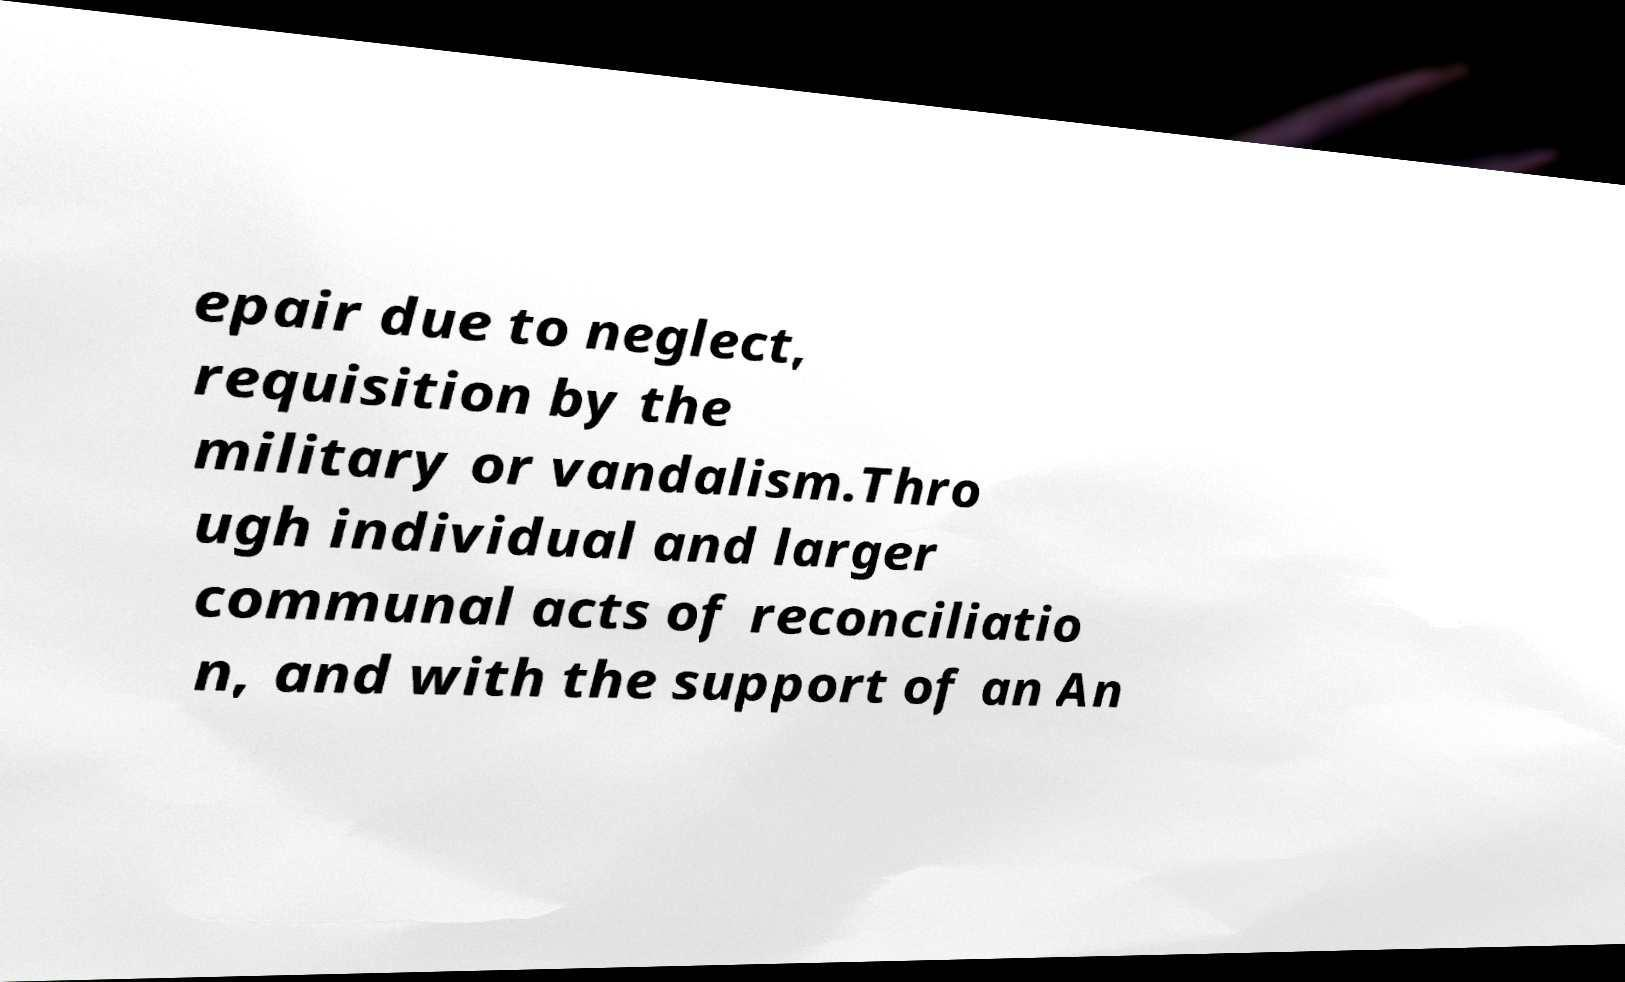Could you extract and type out the text from this image? epair due to neglect, requisition by the military or vandalism.Thro ugh individual and larger communal acts of reconciliatio n, and with the support of an An 